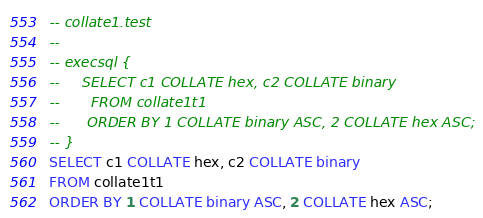<code> <loc_0><loc_0><loc_500><loc_500><_SQL_>-- collate1.test
-- 
-- execsql {
--     SELECT c1 COLLATE hex, c2 COLLATE binary
--       FROM collate1t1 
--      ORDER BY 1 COLLATE binary ASC, 2 COLLATE hex ASC;
-- }
SELECT c1 COLLATE hex, c2 COLLATE binary
FROM collate1t1 
ORDER BY 1 COLLATE binary ASC, 2 COLLATE hex ASC;</code> 